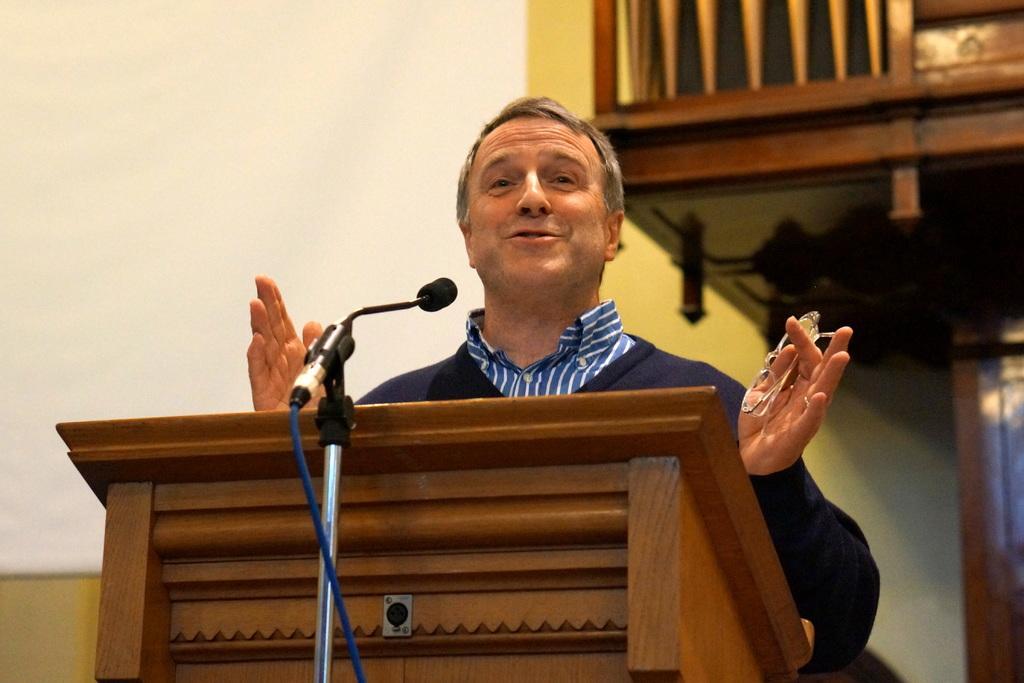In one or two sentences, can you explain what this image depicts? In this image there is a person standing in front of table and speaking in microphone holding glasses, behind him there are some shelves. 